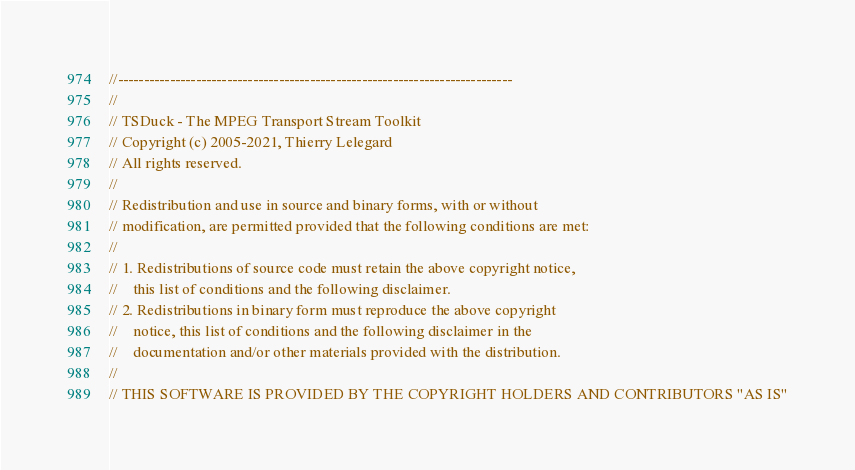Convert code to text. <code><loc_0><loc_0><loc_500><loc_500><_C++_>//----------------------------------------------------------------------------
//
// TSDuck - The MPEG Transport Stream Toolkit
// Copyright (c) 2005-2021, Thierry Lelegard
// All rights reserved.
//
// Redistribution and use in source and binary forms, with or without
// modification, are permitted provided that the following conditions are met:
//
// 1. Redistributions of source code must retain the above copyright notice,
//    this list of conditions and the following disclaimer.
// 2. Redistributions in binary form must reproduce the above copyright
//    notice, this list of conditions and the following disclaimer in the
//    documentation and/or other materials provided with the distribution.
//
// THIS SOFTWARE IS PROVIDED BY THE COPYRIGHT HOLDERS AND CONTRIBUTORS "AS IS"</code> 